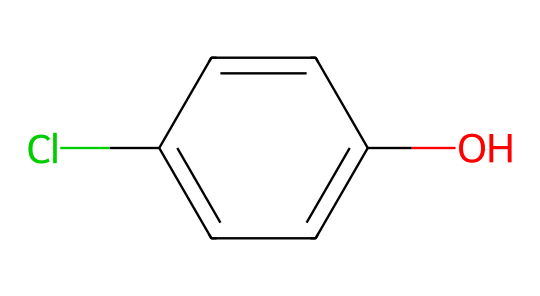What is the name of this compound? Based on the SMILES representation, we can identify it as chlorophenol. The "c" indicates aromatic carbons, "O" denotes a hydroxyl group, and "Cl" indicates a chlorine substituent on the aromatic ring.
Answer: chlorophenol How many chlorine atoms are present? From the SMILES representation, there is one occurrence of "Cl," indicating that there is one chlorine atom attached to the aromatic ring.
Answer: 1 What functional group is present in this molecule? The presence of "O" followed by "c," which signifies a hydroxyl group (-OH) attached to an aromatic carbon, indicates that the functional group in this molecule is a hydroxyl group.
Answer: hydroxyl group What is the total number of carbon atoms in the structure? Counting the number of "c" characters with adjacent hydrogen atoms indicate there are six carbon atoms as part of the aromatic ring in the structure of chlorophenol.
Answer: 6 Which part of the chemical structure is responsible for its potential toxicity? The chlorine substituent ("Cl") on the aromatic ring is known to contribute to the potential toxicity of chlorophenols, affecting both water quality and biological systems.
Answer: chlorine substituent How many hydrogen atoms are directly attached to the carbon atoms in this structure? In the structure, for each carbon that is not substituted by chlorine or bonded to the hydroxyl group, there will be one hydrogen. Since we have six carbons and one is substituted by chlorine and one by hydroxyl, the remaining four carbon atoms can have four hydrogen atoms. Therefore, there are four hydrogen atoms in total.
Answer: 4 Does this compound belong to the phenol type? Yes, since it contains a hydroxyl group (-OH) directly attached to an aromatic ring, it clearly falls under the category of phenols.
Answer: yes 